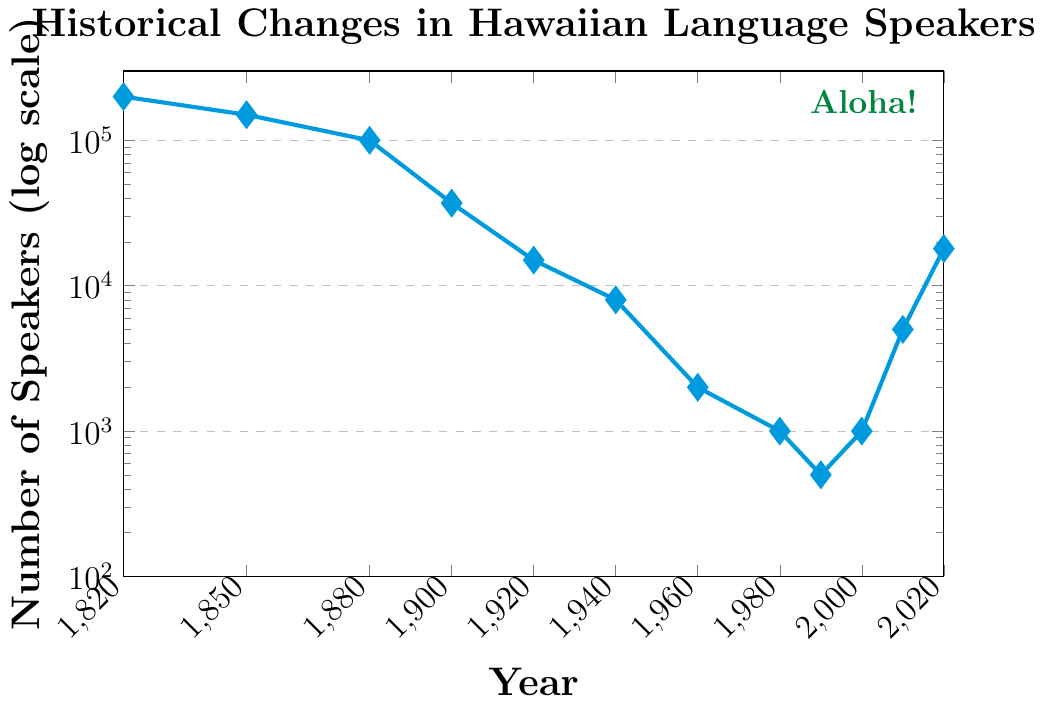How many Hawaiian speakers were there in 2020, and how does this compare to the number of speakers in 2010? In 2020, there were 18,000 Hawaiian speakers. In 2010, there were 5,000. To compare, subtract the 2010 number from the 2020 number: 18,000 - 5,000 = 13,000. Thus, there were 13,000 more speakers in 2020 than in 2010.
Answer: 13,000 When did the number of Hawaiian speakers drop below 10,000 for the first time according to the chart? Refer to the earliest year on the y-axis where the number of speakers is less than 10,000. This first occurred in 1940, as the number of speakers was 8,000.
Answer: 1940 What's the overall trend in the number of Hawaiian speakers from 1820 to 1960? From the data points plotted, there is a clear downward trend in the number of Hawaiian speakers between 1820 (200,000 speakers) and 1960 (2,000 speakers). The numbers consistently decrease each of these years.
Answer: Downward trend What is the ratio of Hawaiian speakers in 1850 compared to 1900? In 1850, there were 150,000 speakers, and in 1900, there were 37,000 speakers. The ratio is calculated as 150,000 / 37,000, which simplifies to approximately 4.05.
Answer: 4.05 How did the number of Hawaiian speakers change between 1900 and 2000, and 2000 and 2020? From 1900 to 2000, the number decreased from 37,000 to 1,000, a reduction of 36,000. From 2000 to 2020, the number increased from 1,000 to 18,000, an increase of 17,000.
Answer: Decreased by 36,000; Increased by 17,000 Which year saw the lowest number of Hawaiian speakers? Find the data point with the smallest value along the y-axis. In 1990, the number was 500, which is the lowest number on the chart.
Answer: 1990 Identify two data points and their corresponding years where there's a significant increase in the number of speakers. The two points where there is a significant increase are from 2000 to 2010 (1,000 to 5,000) and from 2010 to 2020 (5,000 to 18,000).
Answer: 2000 to 2010, 2010 to 2020 What color is used to mark the data points in the figure? The visual attribute of the data points is marked by their color, which can be seen as blue.
Answer: Blue How many more speakers were there in 1820 compared to 1880? In 1820, there were 200,000 speakers, and in 1880, there were 100,000 speakers. Subtract the number in 1880 from 1820: 200,000 - 100,000 = 100,000 more speakers in 1820.
Answer: 100,000 What visual element is included at the top right corner of the chart, and what does it say? The visual element at the top right corner is a text annotation, which says "Aloha!".
Answer: "Aloha!" 